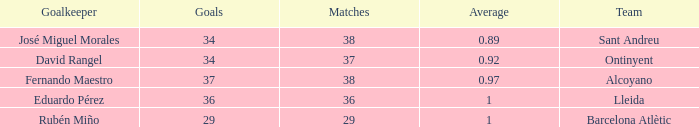What is the maximum mean, when goals is "34", and when matches is fewer than 37? None. 